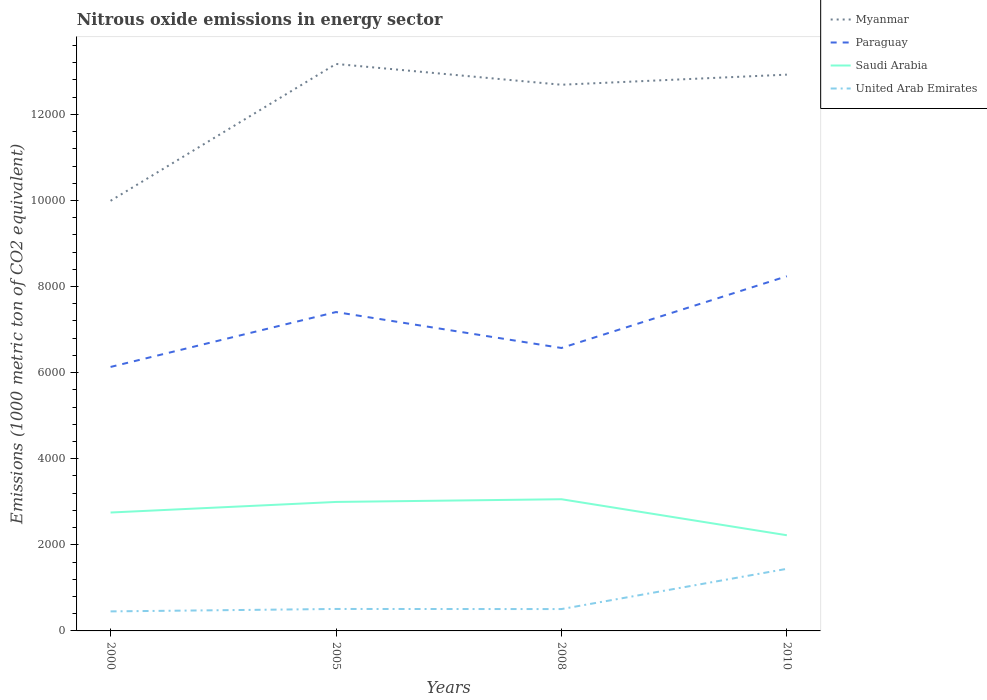Does the line corresponding to Paraguay intersect with the line corresponding to United Arab Emirates?
Keep it short and to the point. No. Across all years, what is the maximum amount of nitrous oxide emitted in United Arab Emirates?
Offer a very short reply. 453.6. In which year was the amount of nitrous oxide emitted in Saudi Arabia maximum?
Your answer should be compact. 2010. What is the total amount of nitrous oxide emitted in Paraguay in the graph?
Your response must be concise. -440.2. What is the difference between the highest and the second highest amount of nitrous oxide emitted in Myanmar?
Keep it short and to the point. 3179.4. What is the difference between the highest and the lowest amount of nitrous oxide emitted in United Arab Emirates?
Your response must be concise. 1. Is the amount of nitrous oxide emitted in United Arab Emirates strictly greater than the amount of nitrous oxide emitted in Saudi Arabia over the years?
Your answer should be compact. Yes. How many lines are there?
Provide a succinct answer. 4. What is the difference between two consecutive major ticks on the Y-axis?
Your answer should be very brief. 2000. Are the values on the major ticks of Y-axis written in scientific E-notation?
Offer a terse response. No. Does the graph contain any zero values?
Offer a terse response. No. How many legend labels are there?
Provide a succinct answer. 4. What is the title of the graph?
Give a very brief answer. Nitrous oxide emissions in energy sector. Does "Ukraine" appear as one of the legend labels in the graph?
Provide a short and direct response. No. What is the label or title of the Y-axis?
Offer a very short reply. Emissions (1000 metric ton of CO2 equivalent). What is the Emissions (1000 metric ton of CO2 equivalent) in Myanmar in 2000?
Make the answer very short. 9992.2. What is the Emissions (1000 metric ton of CO2 equivalent) of Paraguay in 2000?
Your response must be concise. 6132.8. What is the Emissions (1000 metric ton of CO2 equivalent) of Saudi Arabia in 2000?
Your answer should be compact. 2750.6. What is the Emissions (1000 metric ton of CO2 equivalent) of United Arab Emirates in 2000?
Provide a succinct answer. 453.6. What is the Emissions (1000 metric ton of CO2 equivalent) in Myanmar in 2005?
Provide a short and direct response. 1.32e+04. What is the Emissions (1000 metric ton of CO2 equivalent) in Paraguay in 2005?
Provide a succinct answer. 7407.7. What is the Emissions (1000 metric ton of CO2 equivalent) in Saudi Arabia in 2005?
Ensure brevity in your answer.  2996.3. What is the Emissions (1000 metric ton of CO2 equivalent) of United Arab Emirates in 2005?
Provide a succinct answer. 510.2. What is the Emissions (1000 metric ton of CO2 equivalent) of Myanmar in 2008?
Make the answer very short. 1.27e+04. What is the Emissions (1000 metric ton of CO2 equivalent) of Paraguay in 2008?
Provide a short and direct response. 6573. What is the Emissions (1000 metric ton of CO2 equivalent) of Saudi Arabia in 2008?
Offer a terse response. 3059.4. What is the Emissions (1000 metric ton of CO2 equivalent) of United Arab Emirates in 2008?
Offer a terse response. 507.7. What is the Emissions (1000 metric ton of CO2 equivalent) in Myanmar in 2010?
Your answer should be very brief. 1.29e+04. What is the Emissions (1000 metric ton of CO2 equivalent) of Paraguay in 2010?
Keep it short and to the point. 8239.6. What is the Emissions (1000 metric ton of CO2 equivalent) in Saudi Arabia in 2010?
Ensure brevity in your answer.  2222.6. What is the Emissions (1000 metric ton of CO2 equivalent) of United Arab Emirates in 2010?
Give a very brief answer. 1442.7. Across all years, what is the maximum Emissions (1000 metric ton of CO2 equivalent) of Myanmar?
Make the answer very short. 1.32e+04. Across all years, what is the maximum Emissions (1000 metric ton of CO2 equivalent) in Paraguay?
Make the answer very short. 8239.6. Across all years, what is the maximum Emissions (1000 metric ton of CO2 equivalent) in Saudi Arabia?
Make the answer very short. 3059.4. Across all years, what is the maximum Emissions (1000 metric ton of CO2 equivalent) of United Arab Emirates?
Offer a very short reply. 1442.7. Across all years, what is the minimum Emissions (1000 metric ton of CO2 equivalent) in Myanmar?
Offer a terse response. 9992.2. Across all years, what is the minimum Emissions (1000 metric ton of CO2 equivalent) of Paraguay?
Provide a succinct answer. 6132.8. Across all years, what is the minimum Emissions (1000 metric ton of CO2 equivalent) of Saudi Arabia?
Your answer should be compact. 2222.6. Across all years, what is the minimum Emissions (1000 metric ton of CO2 equivalent) of United Arab Emirates?
Make the answer very short. 453.6. What is the total Emissions (1000 metric ton of CO2 equivalent) of Myanmar in the graph?
Your response must be concise. 4.88e+04. What is the total Emissions (1000 metric ton of CO2 equivalent) in Paraguay in the graph?
Offer a very short reply. 2.84e+04. What is the total Emissions (1000 metric ton of CO2 equivalent) of Saudi Arabia in the graph?
Provide a succinct answer. 1.10e+04. What is the total Emissions (1000 metric ton of CO2 equivalent) in United Arab Emirates in the graph?
Offer a very short reply. 2914.2. What is the difference between the Emissions (1000 metric ton of CO2 equivalent) of Myanmar in 2000 and that in 2005?
Keep it short and to the point. -3179.4. What is the difference between the Emissions (1000 metric ton of CO2 equivalent) of Paraguay in 2000 and that in 2005?
Keep it short and to the point. -1274.9. What is the difference between the Emissions (1000 metric ton of CO2 equivalent) in Saudi Arabia in 2000 and that in 2005?
Ensure brevity in your answer.  -245.7. What is the difference between the Emissions (1000 metric ton of CO2 equivalent) in United Arab Emirates in 2000 and that in 2005?
Your answer should be compact. -56.6. What is the difference between the Emissions (1000 metric ton of CO2 equivalent) of Myanmar in 2000 and that in 2008?
Your answer should be very brief. -2696.3. What is the difference between the Emissions (1000 metric ton of CO2 equivalent) of Paraguay in 2000 and that in 2008?
Keep it short and to the point. -440.2. What is the difference between the Emissions (1000 metric ton of CO2 equivalent) in Saudi Arabia in 2000 and that in 2008?
Provide a succinct answer. -308.8. What is the difference between the Emissions (1000 metric ton of CO2 equivalent) of United Arab Emirates in 2000 and that in 2008?
Provide a short and direct response. -54.1. What is the difference between the Emissions (1000 metric ton of CO2 equivalent) in Myanmar in 2000 and that in 2010?
Keep it short and to the point. -2930.9. What is the difference between the Emissions (1000 metric ton of CO2 equivalent) of Paraguay in 2000 and that in 2010?
Make the answer very short. -2106.8. What is the difference between the Emissions (1000 metric ton of CO2 equivalent) of Saudi Arabia in 2000 and that in 2010?
Ensure brevity in your answer.  528. What is the difference between the Emissions (1000 metric ton of CO2 equivalent) of United Arab Emirates in 2000 and that in 2010?
Give a very brief answer. -989.1. What is the difference between the Emissions (1000 metric ton of CO2 equivalent) of Myanmar in 2005 and that in 2008?
Ensure brevity in your answer.  483.1. What is the difference between the Emissions (1000 metric ton of CO2 equivalent) in Paraguay in 2005 and that in 2008?
Your answer should be very brief. 834.7. What is the difference between the Emissions (1000 metric ton of CO2 equivalent) in Saudi Arabia in 2005 and that in 2008?
Your response must be concise. -63.1. What is the difference between the Emissions (1000 metric ton of CO2 equivalent) in United Arab Emirates in 2005 and that in 2008?
Your response must be concise. 2.5. What is the difference between the Emissions (1000 metric ton of CO2 equivalent) in Myanmar in 2005 and that in 2010?
Provide a succinct answer. 248.5. What is the difference between the Emissions (1000 metric ton of CO2 equivalent) of Paraguay in 2005 and that in 2010?
Provide a succinct answer. -831.9. What is the difference between the Emissions (1000 metric ton of CO2 equivalent) in Saudi Arabia in 2005 and that in 2010?
Ensure brevity in your answer.  773.7. What is the difference between the Emissions (1000 metric ton of CO2 equivalent) of United Arab Emirates in 2005 and that in 2010?
Your response must be concise. -932.5. What is the difference between the Emissions (1000 metric ton of CO2 equivalent) of Myanmar in 2008 and that in 2010?
Ensure brevity in your answer.  -234.6. What is the difference between the Emissions (1000 metric ton of CO2 equivalent) of Paraguay in 2008 and that in 2010?
Your response must be concise. -1666.6. What is the difference between the Emissions (1000 metric ton of CO2 equivalent) of Saudi Arabia in 2008 and that in 2010?
Offer a very short reply. 836.8. What is the difference between the Emissions (1000 metric ton of CO2 equivalent) of United Arab Emirates in 2008 and that in 2010?
Provide a succinct answer. -935. What is the difference between the Emissions (1000 metric ton of CO2 equivalent) of Myanmar in 2000 and the Emissions (1000 metric ton of CO2 equivalent) of Paraguay in 2005?
Give a very brief answer. 2584.5. What is the difference between the Emissions (1000 metric ton of CO2 equivalent) in Myanmar in 2000 and the Emissions (1000 metric ton of CO2 equivalent) in Saudi Arabia in 2005?
Provide a succinct answer. 6995.9. What is the difference between the Emissions (1000 metric ton of CO2 equivalent) in Myanmar in 2000 and the Emissions (1000 metric ton of CO2 equivalent) in United Arab Emirates in 2005?
Keep it short and to the point. 9482. What is the difference between the Emissions (1000 metric ton of CO2 equivalent) in Paraguay in 2000 and the Emissions (1000 metric ton of CO2 equivalent) in Saudi Arabia in 2005?
Keep it short and to the point. 3136.5. What is the difference between the Emissions (1000 metric ton of CO2 equivalent) in Paraguay in 2000 and the Emissions (1000 metric ton of CO2 equivalent) in United Arab Emirates in 2005?
Your response must be concise. 5622.6. What is the difference between the Emissions (1000 metric ton of CO2 equivalent) in Saudi Arabia in 2000 and the Emissions (1000 metric ton of CO2 equivalent) in United Arab Emirates in 2005?
Give a very brief answer. 2240.4. What is the difference between the Emissions (1000 metric ton of CO2 equivalent) in Myanmar in 2000 and the Emissions (1000 metric ton of CO2 equivalent) in Paraguay in 2008?
Ensure brevity in your answer.  3419.2. What is the difference between the Emissions (1000 metric ton of CO2 equivalent) in Myanmar in 2000 and the Emissions (1000 metric ton of CO2 equivalent) in Saudi Arabia in 2008?
Make the answer very short. 6932.8. What is the difference between the Emissions (1000 metric ton of CO2 equivalent) in Myanmar in 2000 and the Emissions (1000 metric ton of CO2 equivalent) in United Arab Emirates in 2008?
Keep it short and to the point. 9484.5. What is the difference between the Emissions (1000 metric ton of CO2 equivalent) of Paraguay in 2000 and the Emissions (1000 metric ton of CO2 equivalent) of Saudi Arabia in 2008?
Your answer should be compact. 3073.4. What is the difference between the Emissions (1000 metric ton of CO2 equivalent) in Paraguay in 2000 and the Emissions (1000 metric ton of CO2 equivalent) in United Arab Emirates in 2008?
Make the answer very short. 5625.1. What is the difference between the Emissions (1000 metric ton of CO2 equivalent) of Saudi Arabia in 2000 and the Emissions (1000 metric ton of CO2 equivalent) of United Arab Emirates in 2008?
Offer a very short reply. 2242.9. What is the difference between the Emissions (1000 metric ton of CO2 equivalent) of Myanmar in 2000 and the Emissions (1000 metric ton of CO2 equivalent) of Paraguay in 2010?
Your answer should be compact. 1752.6. What is the difference between the Emissions (1000 metric ton of CO2 equivalent) in Myanmar in 2000 and the Emissions (1000 metric ton of CO2 equivalent) in Saudi Arabia in 2010?
Your response must be concise. 7769.6. What is the difference between the Emissions (1000 metric ton of CO2 equivalent) of Myanmar in 2000 and the Emissions (1000 metric ton of CO2 equivalent) of United Arab Emirates in 2010?
Your answer should be compact. 8549.5. What is the difference between the Emissions (1000 metric ton of CO2 equivalent) of Paraguay in 2000 and the Emissions (1000 metric ton of CO2 equivalent) of Saudi Arabia in 2010?
Your answer should be very brief. 3910.2. What is the difference between the Emissions (1000 metric ton of CO2 equivalent) of Paraguay in 2000 and the Emissions (1000 metric ton of CO2 equivalent) of United Arab Emirates in 2010?
Give a very brief answer. 4690.1. What is the difference between the Emissions (1000 metric ton of CO2 equivalent) in Saudi Arabia in 2000 and the Emissions (1000 metric ton of CO2 equivalent) in United Arab Emirates in 2010?
Your answer should be very brief. 1307.9. What is the difference between the Emissions (1000 metric ton of CO2 equivalent) of Myanmar in 2005 and the Emissions (1000 metric ton of CO2 equivalent) of Paraguay in 2008?
Your response must be concise. 6598.6. What is the difference between the Emissions (1000 metric ton of CO2 equivalent) of Myanmar in 2005 and the Emissions (1000 metric ton of CO2 equivalent) of Saudi Arabia in 2008?
Provide a succinct answer. 1.01e+04. What is the difference between the Emissions (1000 metric ton of CO2 equivalent) in Myanmar in 2005 and the Emissions (1000 metric ton of CO2 equivalent) in United Arab Emirates in 2008?
Keep it short and to the point. 1.27e+04. What is the difference between the Emissions (1000 metric ton of CO2 equivalent) in Paraguay in 2005 and the Emissions (1000 metric ton of CO2 equivalent) in Saudi Arabia in 2008?
Make the answer very short. 4348.3. What is the difference between the Emissions (1000 metric ton of CO2 equivalent) in Paraguay in 2005 and the Emissions (1000 metric ton of CO2 equivalent) in United Arab Emirates in 2008?
Offer a very short reply. 6900. What is the difference between the Emissions (1000 metric ton of CO2 equivalent) of Saudi Arabia in 2005 and the Emissions (1000 metric ton of CO2 equivalent) of United Arab Emirates in 2008?
Make the answer very short. 2488.6. What is the difference between the Emissions (1000 metric ton of CO2 equivalent) of Myanmar in 2005 and the Emissions (1000 metric ton of CO2 equivalent) of Paraguay in 2010?
Give a very brief answer. 4932. What is the difference between the Emissions (1000 metric ton of CO2 equivalent) in Myanmar in 2005 and the Emissions (1000 metric ton of CO2 equivalent) in Saudi Arabia in 2010?
Your response must be concise. 1.09e+04. What is the difference between the Emissions (1000 metric ton of CO2 equivalent) of Myanmar in 2005 and the Emissions (1000 metric ton of CO2 equivalent) of United Arab Emirates in 2010?
Give a very brief answer. 1.17e+04. What is the difference between the Emissions (1000 metric ton of CO2 equivalent) of Paraguay in 2005 and the Emissions (1000 metric ton of CO2 equivalent) of Saudi Arabia in 2010?
Offer a terse response. 5185.1. What is the difference between the Emissions (1000 metric ton of CO2 equivalent) of Paraguay in 2005 and the Emissions (1000 metric ton of CO2 equivalent) of United Arab Emirates in 2010?
Your answer should be very brief. 5965. What is the difference between the Emissions (1000 metric ton of CO2 equivalent) in Saudi Arabia in 2005 and the Emissions (1000 metric ton of CO2 equivalent) in United Arab Emirates in 2010?
Ensure brevity in your answer.  1553.6. What is the difference between the Emissions (1000 metric ton of CO2 equivalent) of Myanmar in 2008 and the Emissions (1000 metric ton of CO2 equivalent) of Paraguay in 2010?
Provide a short and direct response. 4448.9. What is the difference between the Emissions (1000 metric ton of CO2 equivalent) of Myanmar in 2008 and the Emissions (1000 metric ton of CO2 equivalent) of Saudi Arabia in 2010?
Your answer should be compact. 1.05e+04. What is the difference between the Emissions (1000 metric ton of CO2 equivalent) in Myanmar in 2008 and the Emissions (1000 metric ton of CO2 equivalent) in United Arab Emirates in 2010?
Provide a succinct answer. 1.12e+04. What is the difference between the Emissions (1000 metric ton of CO2 equivalent) of Paraguay in 2008 and the Emissions (1000 metric ton of CO2 equivalent) of Saudi Arabia in 2010?
Provide a short and direct response. 4350.4. What is the difference between the Emissions (1000 metric ton of CO2 equivalent) in Paraguay in 2008 and the Emissions (1000 metric ton of CO2 equivalent) in United Arab Emirates in 2010?
Your response must be concise. 5130.3. What is the difference between the Emissions (1000 metric ton of CO2 equivalent) in Saudi Arabia in 2008 and the Emissions (1000 metric ton of CO2 equivalent) in United Arab Emirates in 2010?
Provide a short and direct response. 1616.7. What is the average Emissions (1000 metric ton of CO2 equivalent) of Myanmar per year?
Offer a very short reply. 1.22e+04. What is the average Emissions (1000 metric ton of CO2 equivalent) of Paraguay per year?
Make the answer very short. 7088.27. What is the average Emissions (1000 metric ton of CO2 equivalent) in Saudi Arabia per year?
Keep it short and to the point. 2757.22. What is the average Emissions (1000 metric ton of CO2 equivalent) in United Arab Emirates per year?
Provide a short and direct response. 728.55. In the year 2000, what is the difference between the Emissions (1000 metric ton of CO2 equivalent) in Myanmar and Emissions (1000 metric ton of CO2 equivalent) in Paraguay?
Your response must be concise. 3859.4. In the year 2000, what is the difference between the Emissions (1000 metric ton of CO2 equivalent) of Myanmar and Emissions (1000 metric ton of CO2 equivalent) of Saudi Arabia?
Make the answer very short. 7241.6. In the year 2000, what is the difference between the Emissions (1000 metric ton of CO2 equivalent) of Myanmar and Emissions (1000 metric ton of CO2 equivalent) of United Arab Emirates?
Offer a very short reply. 9538.6. In the year 2000, what is the difference between the Emissions (1000 metric ton of CO2 equivalent) in Paraguay and Emissions (1000 metric ton of CO2 equivalent) in Saudi Arabia?
Your response must be concise. 3382.2. In the year 2000, what is the difference between the Emissions (1000 metric ton of CO2 equivalent) of Paraguay and Emissions (1000 metric ton of CO2 equivalent) of United Arab Emirates?
Your answer should be compact. 5679.2. In the year 2000, what is the difference between the Emissions (1000 metric ton of CO2 equivalent) of Saudi Arabia and Emissions (1000 metric ton of CO2 equivalent) of United Arab Emirates?
Give a very brief answer. 2297. In the year 2005, what is the difference between the Emissions (1000 metric ton of CO2 equivalent) in Myanmar and Emissions (1000 metric ton of CO2 equivalent) in Paraguay?
Provide a short and direct response. 5763.9. In the year 2005, what is the difference between the Emissions (1000 metric ton of CO2 equivalent) of Myanmar and Emissions (1000 metric ton of CO2 equivalent) of Saudi Arabia?
Provide a short and direct response. 1.02e+04. In the year 2005, what is the difference between the Emissions (1000 metric ton of CO2 equivalent) in Myanmar and Emissions (1000 metric ton of CO2 equivalent) in United Arab Emirates?
Offer a very short reply. 1.27e+04. In the year 2005, what is the difference between the Emissions (1000 metric ton of CO2 equivalent) of Paraguay and Emissions (1000 metric ton of CO2 equivalent) of Saudi Arabia?
Keep it short and to the point. 4411.4. In the year 2005, what is the difference between the Emissions (1000 metric ton of CO2 equivalent) in Paraguay and Emissions (1000 metric ton of CO2 equivalent) in United Arab Emirates?
Ensure brevity in your answer.  6897.5. In the year 2005, what is the difference between the Emissions (1000 metric ton of CO2 equivalent) in Saudi Arabia and Emissions (1000 metric ton of CO2 equivalent) in United Arab Emirates?
Your answer should be very brief. 2486.1. In the year 2008, what is the difference between the Emissions (1000 metric ton of CO2 equivalent) of Myanmar and Emissions (1000 metric ton of CO2 equivalent) of Paraguay?
Keep it short and to the point. 6115.5. In the year 2008, what is the difference between the Emissions (1000 metric ton of CO2 equivalent) in Myanmar and Emissions (1000 metric ton of CO2 equivalent) in Saudi Arabia?
Give a very brief answer. 9629.1. In the year 2008, what is the difference between the Emissions (1000 metric ton of CO2 equivalent) in Myanmar and Emissions (1000 metric ton of CO2 equivalent) in United Arab Emirates?
Provide a succinct answer. 1.22e+04. In the year 2008, what is the difference between the Emissions (1000 metric ton of CO2 equivalent) of Paraguay and Emissions (1000 metric ton of CO2 equivalent) of Saudi Arabia?
Your response must be concise. 3513.6. In the year 2008, what is the difference between the Emissions (1000 metric ton of CO2 equivalent) in Paraguay and Emissions (1000 metric ton of CO2 equivalent) in United Arab Emirates?
Your answer should be very brief. 6065.3. In the year 2008, what is the difference between the Emissions (1000 metric ton of CO2 equivalent) in Saudi Arabia and Emissions (1000 metric ton of CO2 equivalent) in United Arab Emirates?
Offer a terse response. 2551.7. In the year 2010, what is the difference between the Emissions (1000 metric ton of CO2 equivalent) in Myanmar and Emissions (1000 metric ton of CO2 equivalent) in Paraguay?
Give a very brief answer. 4683.5. In the year 2010, what is the difference between the Emissions (1000 metric ton of CO2 equivalent) in Myanmar and Emissions (1000 metric ton of CO2 equivalent) in Saudi Arabia?
Your answer should be compact. 1.07e+04. In the year 2010, what is the difference between the Emissions (1000 metric ton of CO2 equivalent) of Myanmar and Emissions (1000 metric ton of CO2 equivalent) of United Arab Emirates?
Provide a succinct answer. 1.15e+04. In the year 2010, what is the difference between the Emissions (1000 metric ton of CO2 equivalent) in Paraguay and Emissions (1000 metric ton of CO2 equivalent) in Saudi Arabia?
Your answer should be compact. 6017. In the year 2010, what is the difference between the Emissions (1000 metric ton of CO2 equivalent) of Paraguay and Emissions (1000 metric ton of CO2 equivalent) of United Arab Emirates?
Your answer should be compact. 6796.9. In the year 2010, what is the difference between the Emissions (1000 metric ton of CO2 equivalent) in Saudi Arabia and Emissions (1000 metric ton of CO2 equivalent) in United Arab Emirates?
Offer a very short reply. 779.9. What is the ratio of the Emissions (1000 metric ton of CO2 equivalent) of Myanmar in 2000 to that in 2005?
Keep it short and to the point. 0.76. What is the ratio of the Emissions (1000 metric ton of CO2 equivalent) of Paraguay in 2000 to that in 2005?
Your response must be concise. 0.83. What is the ratio of the Emissions (1000 metric ton of CO2 equivalent) of Saudi Arabia in 2000 to that in 2005?
Make the answer very short. 0.92. What is the ratio of the Emissions (1000 metric ton of CO2 equivalent) of United Arab Emirates in 2000 to that in 2005?
Your answer should be compact. 0.89. What is the ratio of the Emissions (1000 metric ton of CO2 equivalent) in Myanmar in 2000 to that in 2008?
Your answer should be compact. 0.79. What is the ratio of the Emissions (1000 metric ton of CO2 equivalent) of Paraguay in 2000 to that in 2008?
Offer a terse response. 0.93. What is the ratio of the Emissions (1000 metric ton of CO2 equivalent) of Saudi Arabia in 2000 to that in 2008?
Make the answer very short. 0.9. What is the ratio of the Emissions (1000 metric ton of CO2 equivalent) in United Arab Emirates in 2000 to that in 2008?
Ensure brevity in your answer.  0.89. What is the ratio of the Emissions (1000 metric ton of CO2 equivalent) in Myanmar in 2000 to that in 2010?
Keep it short and to the point. 0.77. What is the ratio of the Emissions (1000 metric ton of CO2 equivalent) in Paraguay in 2000 to that in 2010?
Provide a short and direct response. 0.74. What is the ratio of the Emissions (1000 metric ton of CO2 equivalent) in Saudi Arabia in 2000 to that in 2010?
Your answer should be compact. 1.24. What is the ratio of the Emissions (1000 metric ton of CO2 equivalent) of United Arab Emirates in 2000 to that in 2010?
Ensure brevity in your answer.  0.31. What is the ratio of the Emissions (1000 metric ton of CO2 equivalent) in Myanmar in 2005 to that in 2008?
Offer a terse response. 1.04. What is the ratio of the Emissions (1000 metric ton of CO2 equivalent) of Paraguay in 2005 to that in 2008?
Give a very brief answer. 1.13. What is the ratio of the Emissions (1000 metric ton of CO2 equivalent) of Saudi Arabia in 2005 to that in 2008?
Keep it short and to the point. 0.98. What is the ratio of the Emissions (1000 metric ton of CO2 equivalent) of United Arab Emirates in 2005 to that in 2008?
Give a very brief answer. 1. What is the ratio of the Emissions (1000 metric ton of CO2 equivalent) of Myanmar in 2005 to that in 2010?
Your answer should be compact. 1.02. What is the ratio of the Emissions (1000 metric ton of CO2 equivalent) in Paraguay in 2005 to that in 2010?
Provide a short and direct response. 0.9. What is the ratio of the Emissions (1000 metric ton of CO2 equivalent) in Saudi Arabia in 2005 to that in 2010?
Your answer should be very brief. 1.35. What is the ratio of the Emissions (1000 metric ton of CO2 equivalent) of United Arab Emirates in 2005 to that in 2010?
Your answer should be compact. 0.35. What is the ratio of the Emissions (1000 metric ton of CO2 equivalent) of Myanmar in 2008 to that in 2010?
Offer a very short reply. 0.98. What is the ratio of the Emissions (1000 metric ton of CO2 equivalent) of Paraguay in 2008 to that in 2010?
Offer a very short reply. 0.8. What is the ratio of the Emissions (1000 metric ton of CO2 equivalent) in Saudi Arabia in 2008 to that in 2010?
Make the answer very short. 1.38. What is the ratio of the Emissions (1000 metric ton of CO2 equivalent) in United Arab Emirates in 2008 to that in 2010?
Offer a very short reply. 0.35. What is the difference between the highest and the second highest Emissions (1000 metric ton of CO2 equivalent) of Myanmar?
Give a very brief answer. 248.5. What is the difference between the highest and the second highest Emissions (1000 metric ton of CO2 equivalent) in Paraguay?
Provide a short and direct response. 831.9. What is the difference between the highest and the second highest Emissions (1000 metric ton of CO2 equivalent) in Saudi Arabia?
Your answer should be compact. 63.1. What is the difference between the highest and the second highest Emissions (1000 metric ton of CO2 equivalent) in United Arab Emirates?
Give a very brief answer. 932.5. What is the difference between the highest and the lowest Emissions (1000 metric ton of CO2 equivalent) of Myanmar?
Your answer should be compact. 3179.4. What is the difference between the highest and the lowest Emissions (1000 metric ton of CO2 equivalent) in Paraguay?
Offer a terse response. 2106.8. What is the difference between the highest and the lowest Emissions (1000 metric ton of CO2 equivalent) of Saudi Arabia?
Offer a very short reply. 836.8. What is the difference between the highest and the lowest Emissions (1000 metric ton of CO2 equivalent) in United Arab Emirates?
Ensure brevity in your answer.  989.1. 